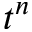Convert formula to latex. <formula><loc_0><loc_0><loc_500><loc_500>t ^ { n }</formula> 